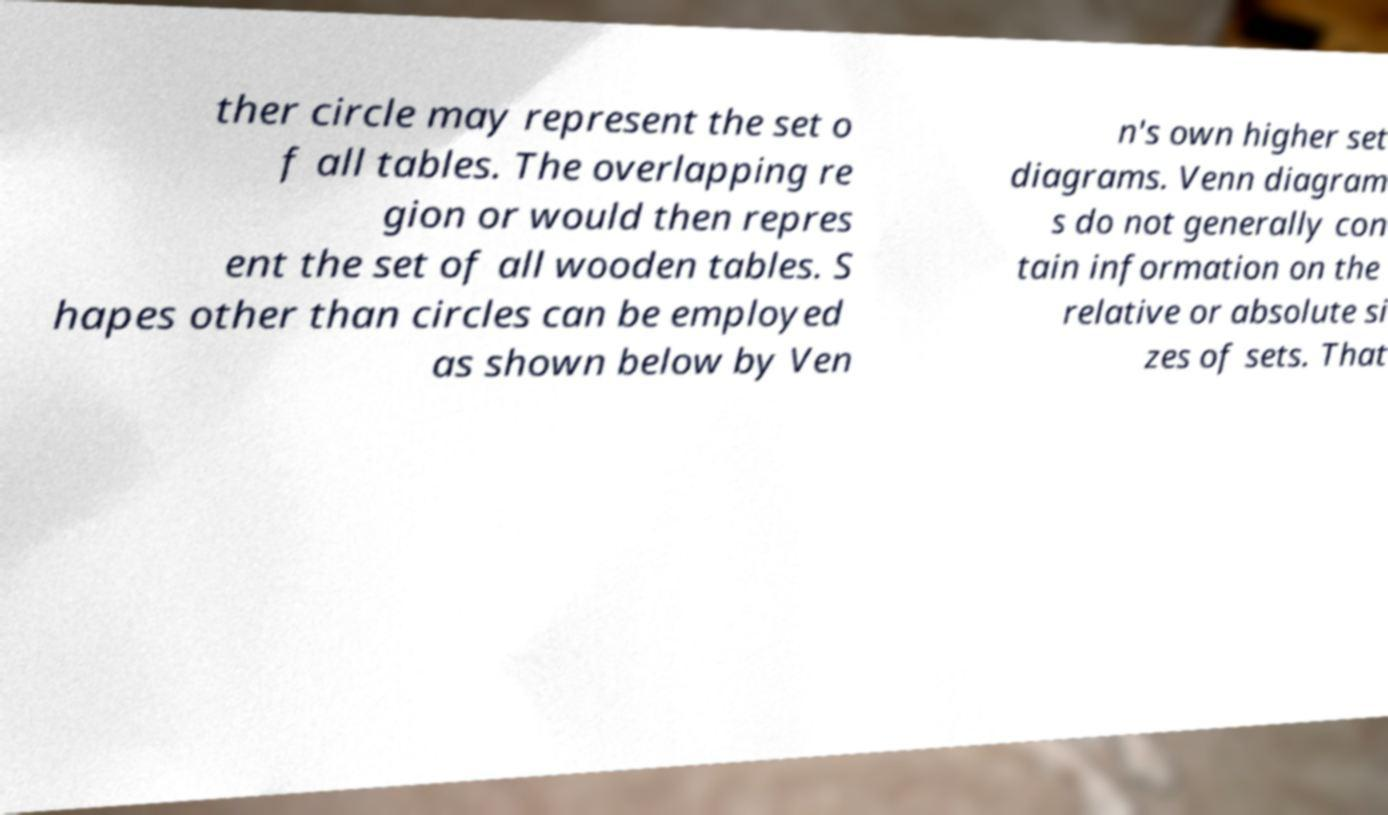I need the written content from this picture converted into text. Can you do that? ther circle may represent the set o f all tables. The overlapping re gion or would then repres ent the set of all wooden tables. S hapes other than circles can be employed as shown below by Ven n's own higher set diagrams. Venn diagram s do not generally con tain information on the relative or absolute si zes of sets. That 